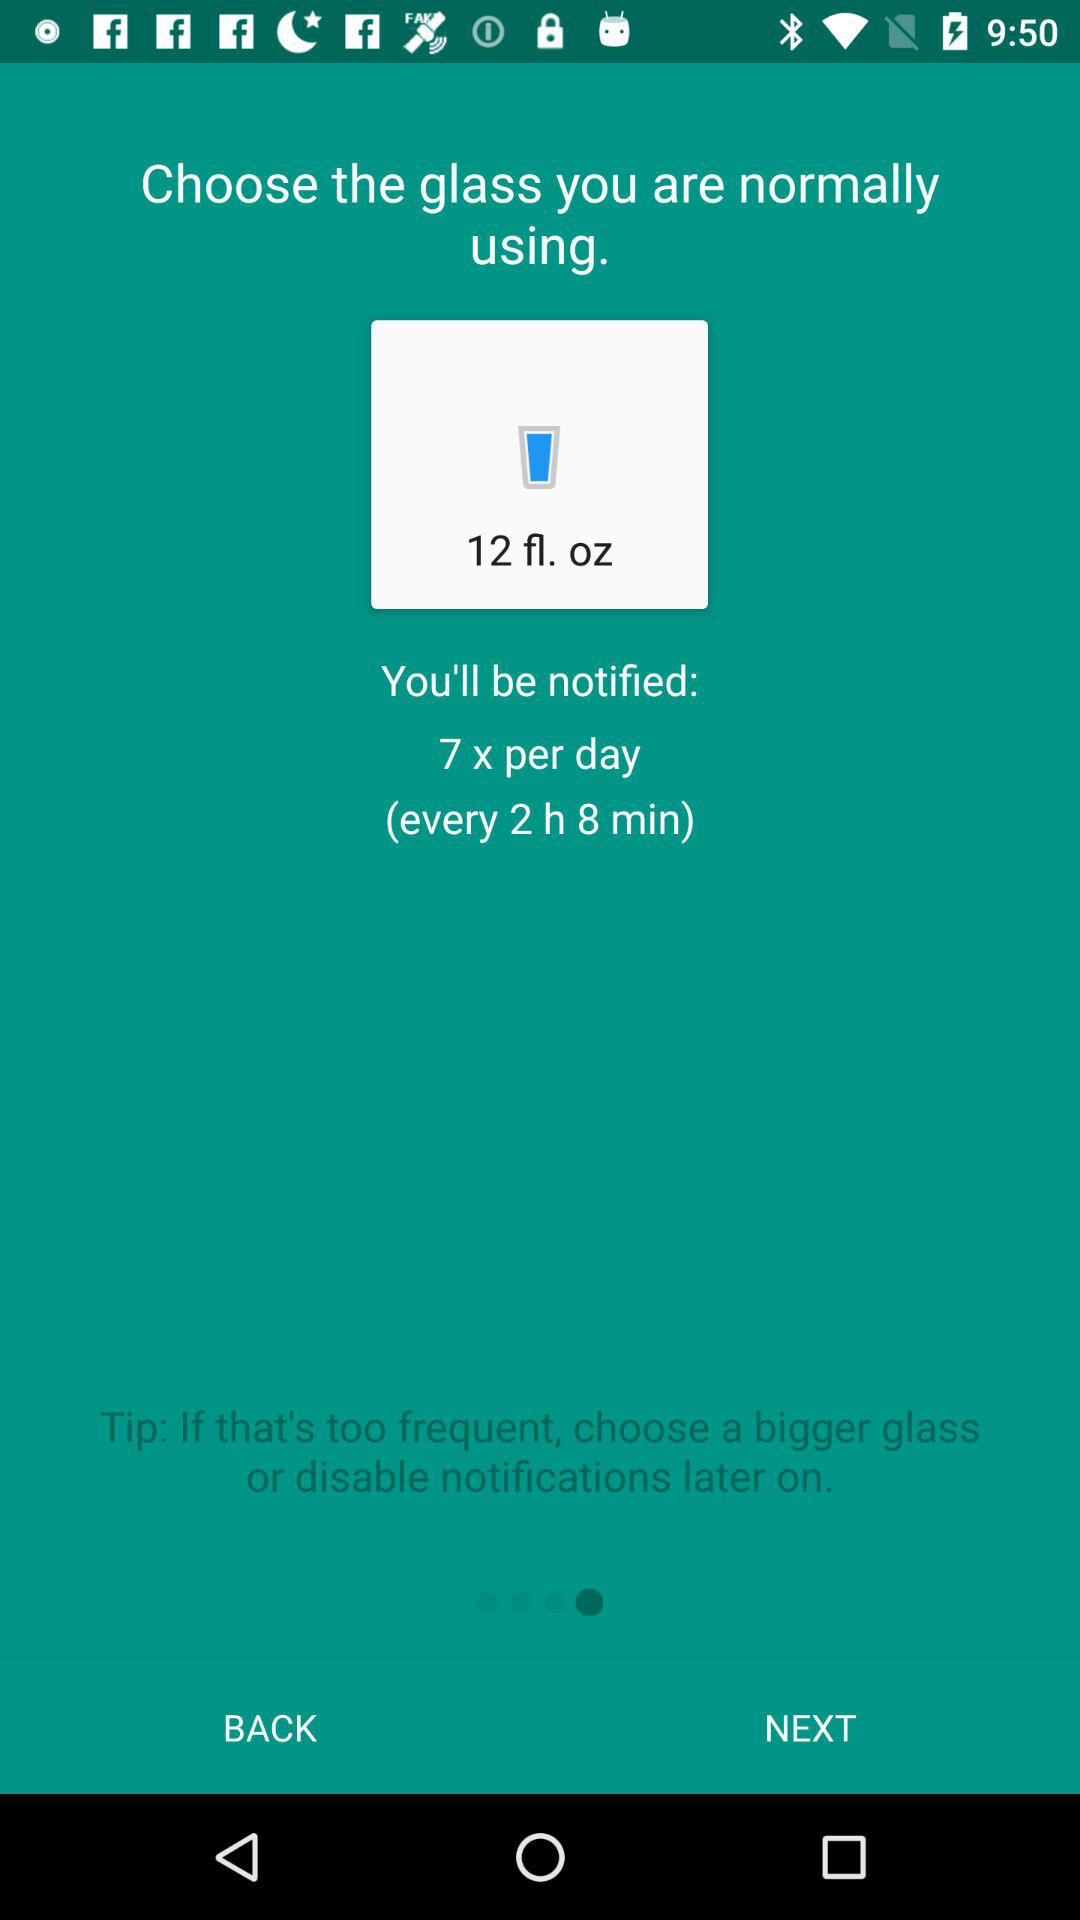How many times will I be notified per day? You will be notified 7 times per day. 